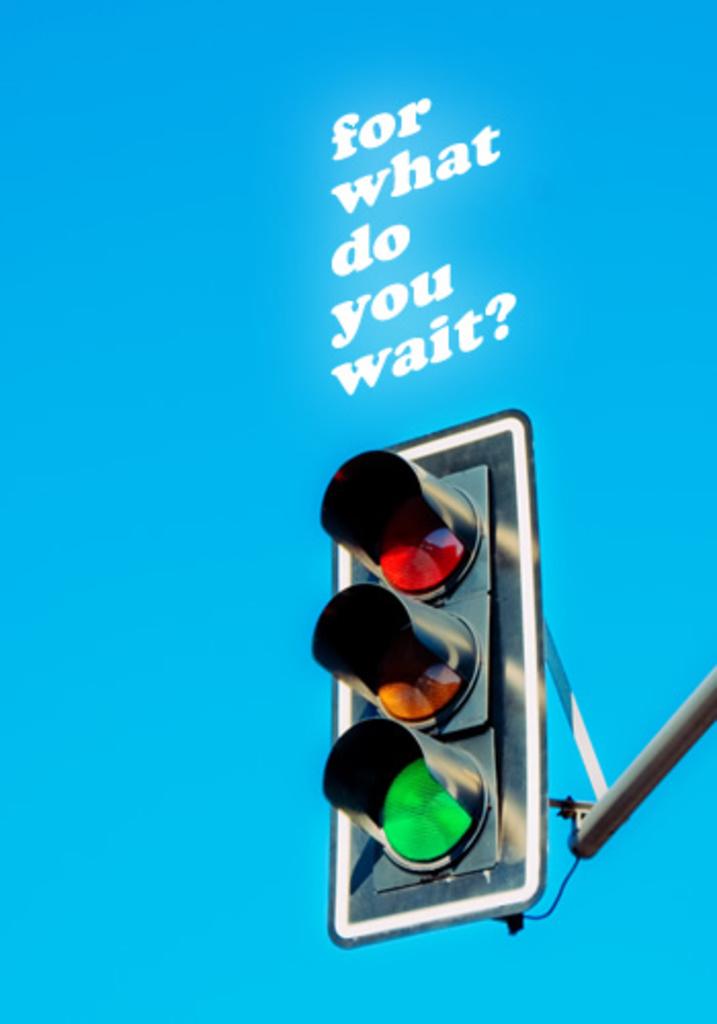What is below the text?
Your response must be concise. Answering does not require reading text in the image. 